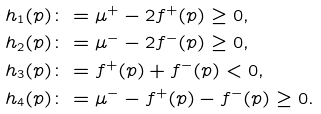Convert formula to latex. <formula><loc_0><loc_0><loc_500><loc_500>h _ { 1 } ( p ) & \colon = \mu ^ { + } - 2 f ^ { + } ( p ) \geq 0 , \\ h _ { 2 } ( p ) & \colon = \mu ^ { - } - 2 f ^ { - } ( p ) \geq 0 , \\ h _ { 3 } ( p ) & \colon = f ^ { + } ( p ) + f ^ { - } ( p ) < 0 , \\ h _ { 4 } ( p ) & \colon = \mu ^ { - } - f ^ { + } ( p ) - f ^ { - } ( p ) \geq 0 .</formula> 